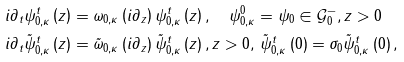<formula> <loc_0><loc_0><loc_500><loc_500>i \partial _ { t } \psi _ { 0 , \kappa } ^ { t } \left ( z \right ) & = \omega _ { 0 , \kappa } \left ( i \partial _ { z } \right ) \psi _ { 0 , \kappa } ^ { t } \left ( z \right ) , \quad \psi _ { 0 , \kappa } ^ { 0 } = \psi _ { 0 } \in \mathcal { G } _ { 0 } ^ { - } , z > 0 \\ i \partial _ { t } \tilde { \psi } _ { 0 , \kappa } ^ { t } \left ( z \right ) & = \tilde { \omega } _ { 0 , \kappa } \left ( i \partial _ { z } \right ) \tilde { \psi } _ { 0 , \kappa } ^ { t } \left ( z \right ) , z > 0 , \, \tilde { \psi } _ { 0 , \kappa } ^ { t } \left ( 0 \right ) = \sigma _ { 0 } \tilde { \psi } _ { 0 , \kappa } ^ { t } \left ( 0 \right ) ,</formula> 